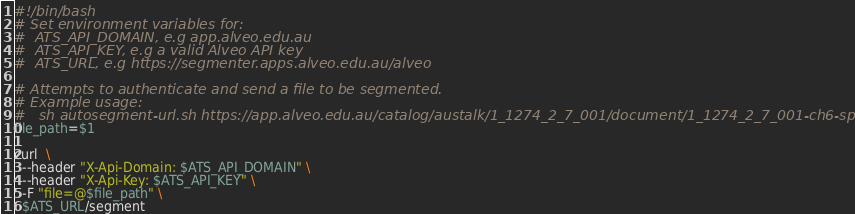Convert code to text. <code><loc_0><loc_0><loc_500><loc_500><_Bash_>#!/bin/bash
# Set environment variables for:
#  ATS_API_DOMAIN, e.g app.alveo.edu.au
#  ATS_API_KEY, e.g a valid Alveo API key
#  ATS_URL, e.g https://segmenter.apps.alveo.edu.au/alveo

# Attempts to authenticate and send a file to be segmented.
# Example usage:
#   sh autosegment-url.sh https://app.alveo.edu.au/catalog/austalk/1_1274_2_7_001/document/1_1274_2_7_001-ch6-speaker16.wav
file_path=$1

curl  \
  --header "X-Api-Domain: $ATS_API_DOMAIN" \
  --header "X-Api-Key: $ATS_API_KEY" \
  -F "file=@$file_path" \
  $ATS_URL/segment
</code> 